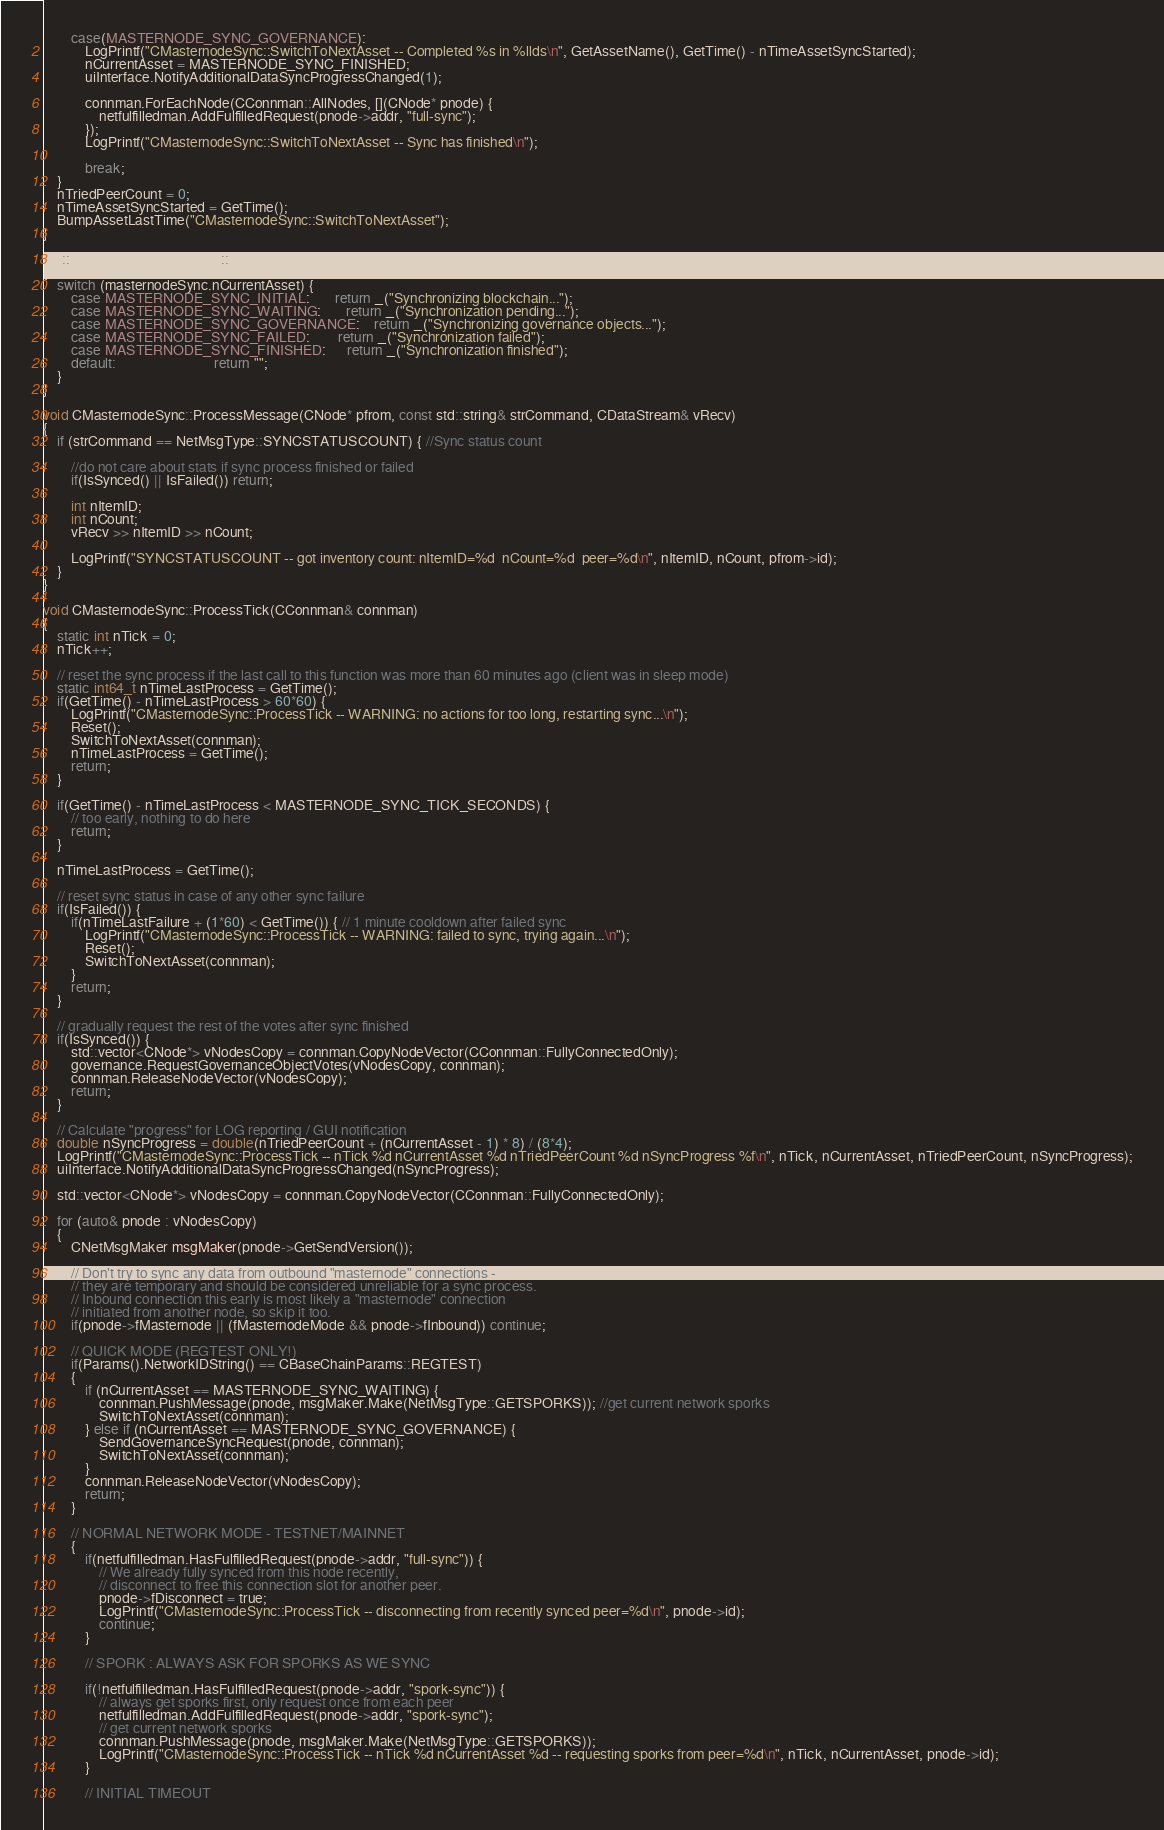<code> <loc_0><loc_0><loc_500><loc_500><_C++_>        case(MASTERNODE_SYNC_GOVERNANCE):
            LogPrintf("CMasternodeSync::SwitchToNextAsset -- Completed %s in %llds\n", GetAssetName(), GetTime() - nTimeAssetSyncStarted);
            nCurrentAsset = MASTERNODE_SYNC_FINISHED;
            uiInterface.NotifyAdditionalDataSyncProgressChanged(1);

            connman.ForEachNode(CConnman::AllNodes, [](CNode* pnode) {
                netfulfilledman.AddFulfilledRequest(pnode->addr, "full-sync");
            });
            LogPrintf("CMasternodeSync::SwitchToNextAsset -- Sync has finished\n");

            break;
    }
    nTriedPeerCount = 0;
    nTimeAssetSyncStarted = GetTime();
    BumpAssetLastTime("CMasternodeSync::SwitchToNextAsset");
}

std::string CMasternodeSync::GetSyncStatus()
{
    switch (masternodeSync.nCurrentAsset) {
        case MASTERNODE_SYNC_INITIAL:       return _("Synchronizing blockchain...");
        case MASTERNODE_SYNC_WAITING:       return _("Synchronization pending...");
        case MASTERNODE_SYNC_GOVERNANCE:    return _("Synchronizing governance objects...");
        case MASTERNODE_SYNC_FAILED:        return _("Synchronization failed");
        case MASTERNODE_SYNC_FINISHED:      return _("Synchronization finished");
        default:                            return "";
    }
}

void CMasternodeSync::ProcessMessage(CNode* pfrom, const std::string& strCommand, CDataStream& vRecv)
{
    if (strCommand == NetMsgType::SYNCSTATUSCOUNT) { //Sync status count

        //do not care about stats if sync process finished or failed
        if(IsSynced() || IsFailed()) return;

        int nItemID;
        int nCount;
        vRecv >> nItemID >> nCount;

        LogPrintf("SYNCSTATUSCOUNT -- got inventory count: nItemID=%d  nCount=%d  peer=%d\n", nItemID, nCount, pfrom->id);
    }
}

void CMasternodeSync::ProcessTick(CConnman& connman)
{
    static int nTick = 0;
    nTick++;

    // reset the sync process if the last call to this function was more than 60 minutes ago (client was in sleep mode)
    static int64_t nTimeLastProcess = GetTime();
    if(GetTime() - nTimeLastProcess > 60*60) {
        LogPrintf("CMasternodeSync::ProcessTick -- WARNING: no actions for too long, restarting sync...\n");
        Reset();
        SwitchToNextAsset(connman);
        nTimeLastProcess = GetTime();
        return;
    }

    if(GetTime() - nTimeLastProcess < MASTERNODE_SYNC_TICK_SECONDS) {
        // too early, nothing to do here
        return;
    }

    nTimeLastProcess = GetTime();

    // reset sync status in case of any other sync failure
    if(IsFailed()) {
        if(nTimeLastFailure + (1*60) < GetTime()) { // 1 minute cooldown after failed sync
            LogPrintf("CMasternodeSync::ProcessTick -- WARNING: failed to sync, trying again...\n");
            Reset();
            SwitchToNextAsset(connman);
        }
        return;
    }

    // gradually request the rest of the votes after sync finished
    if(IsSynced()) {
        std::vector<CNode*> vNodesCopy = connman.CopyNodeVector(CConnman::FullyConnectedOnly);
        governance.RequestGovernanceObjectVotes(vNodesCopy, connman);
        connman.ReleaseNodeVector(vNodesCopy);
        return;
    }

    // Calculate "progress" for LOG reporting / GUI notification
    double nSyncProgress = double(nTriedPeerCount + (nCurrentAsset - 1) * 8) / (8*4);
    LogPrintf("CMasternodeSync::ProcessTick -- nTick %d nCurrentAsset %d nTriedPeerCount %d nSyncProgress %f\n", nTick, nCurrentAsset, nTriedPeerCount, nSyncProgress);
    uiInterface.NotifyAdditionalDataSyncProgressChanged(nSyncProgress);

    std::vector<CNode*> vNodesCopy = connman.CopyNodeVector(CConnman::FullyConnectedOnly);

    for (auto& pnode : vNodesCopy)
    {
        CNetMsgMaker msgMaker(pnode->GetSendVersion());

        // Don't try to sync any data from outbound "masternode" connections -
        // they are temporary and should be considered unreliable for a sync process.
        // Inbound connection this early is most likely a "masternode" connection
        // initiated from another node, so skip it too.
        if(pnode->fMasternode || (fMasternodeMode && pnode->fInbound)) continue;

        // QUICK MODE (REGTEST ONLY!)
        if(Params().NetworkIDString() == CBaseChainParams::REGTEST)
        {
            if (nCurrentAsset == MASTERNODE_SYNC_WAITING) {
                connman.PushMessage(pnode, msgMaker.Make(NetMsgType::GETSPORKS)); //get current network sporks
                SwitchToNextAsset(connman);
            } else if (nCurrentAsset == MASTERNODE_SYNC_GOVERNANCE) {
                SendGovernanceSyncRequest(pnode, connman);
                SwitchToNextAsset(connman);
            }
            connman.ReleaseNodeVector(vNodesCopy);
            return;
        }

        // NORMAL NETWORK MODE - TESTNET/MAINNET
        {
            if(netfulfilledman.HasFulfilledRequest(pnode->addr, "full-sync")) {
                // We already fully synced from this node recently,
                // disconnect to free this connection slot for another peer.
                pnode->fDisconnect = true;
                LogPrintf("CMasternodeSync::ProcessTick -- disconnecting from recently synced peer=%d\n", pnode->id);
                continue;
            }

            // SPORK : ALWAYS ASK FOR SPORKS AS WE SYNC

            if(!netfulfilledman.HasFulfilledRequest(pnode->addr, "spork-sync")) {
                // always get sporks first, only request once from each peer
                netfulfilledman.AddFulfilledRequest(pnode->addr, "spork-sync");
                // get current network sporks
                connman.PushMessage(pnode, msgMaker.Make(NetMsgType::GETSPORKS));
                LogPrintf("CMasternodeSync::ProcessTick -- nTick %d nCurrentAsset %d -- requesting sporks from peer=%d\n", nTick, nCurrentAsset, pnode->id);
            }

            // INITIAL TIMEOUT
</code> 